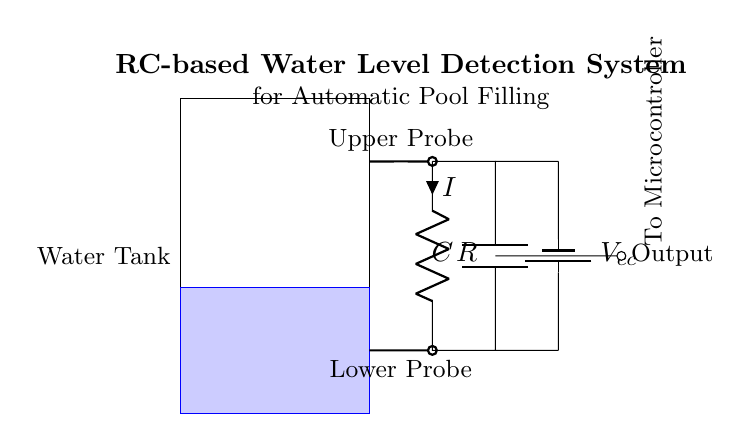What are the two types of probes in the circuit? The circuit contains an upper probe and a lower probe which are used for water level detection. The upper probe is positioned at the higher level and the lower probe at the lower level of the water tank.
Answer: Upper probe, Lower probe What is the component labeled C in the circuit? The component labeled C is a capacitor, which is a key element in the RC circuit used for sensing changes in voltage due to water level variations.
Answer: Capacitor What is the purpose of the resistor in this circuit? The resistor is used to limit the current flowing through the circuit, which helps to control the charging time of the capacitor and therefore affects the sensitivity of the water level detection.
Answer: To limit current What is the expected voltage source in this circuit? The circuit diagram shows a battery labeled Vcc as the voltage source, which provides the necessary electrical energy for the operation of the RC circuit.
Answer: Vcc How many components are in the RC circuit section? The RC circuit section includes two components: one resistor and one capacitor, which work together to detect water levels.
Answer: Two What happens to the output if the water level rises above the upper probe? If the water level rises above the upper probe, the voltage across the capacitor will change, causing the output to signal that the water level is at a sufficient height, typically resulting in a triggering of an automatic filling mechanism.
Answer: The output signals water level is sufficient What is the significance of the location of the probes in the circuit? The location of the probes is significant because it determines the different water level thresholds; the upper probe indicates the maximum fill level while the lower probe indicates the minimum fill level, allowing for automatic management of the pool's water level.
Answer: Determines water level thresholds 